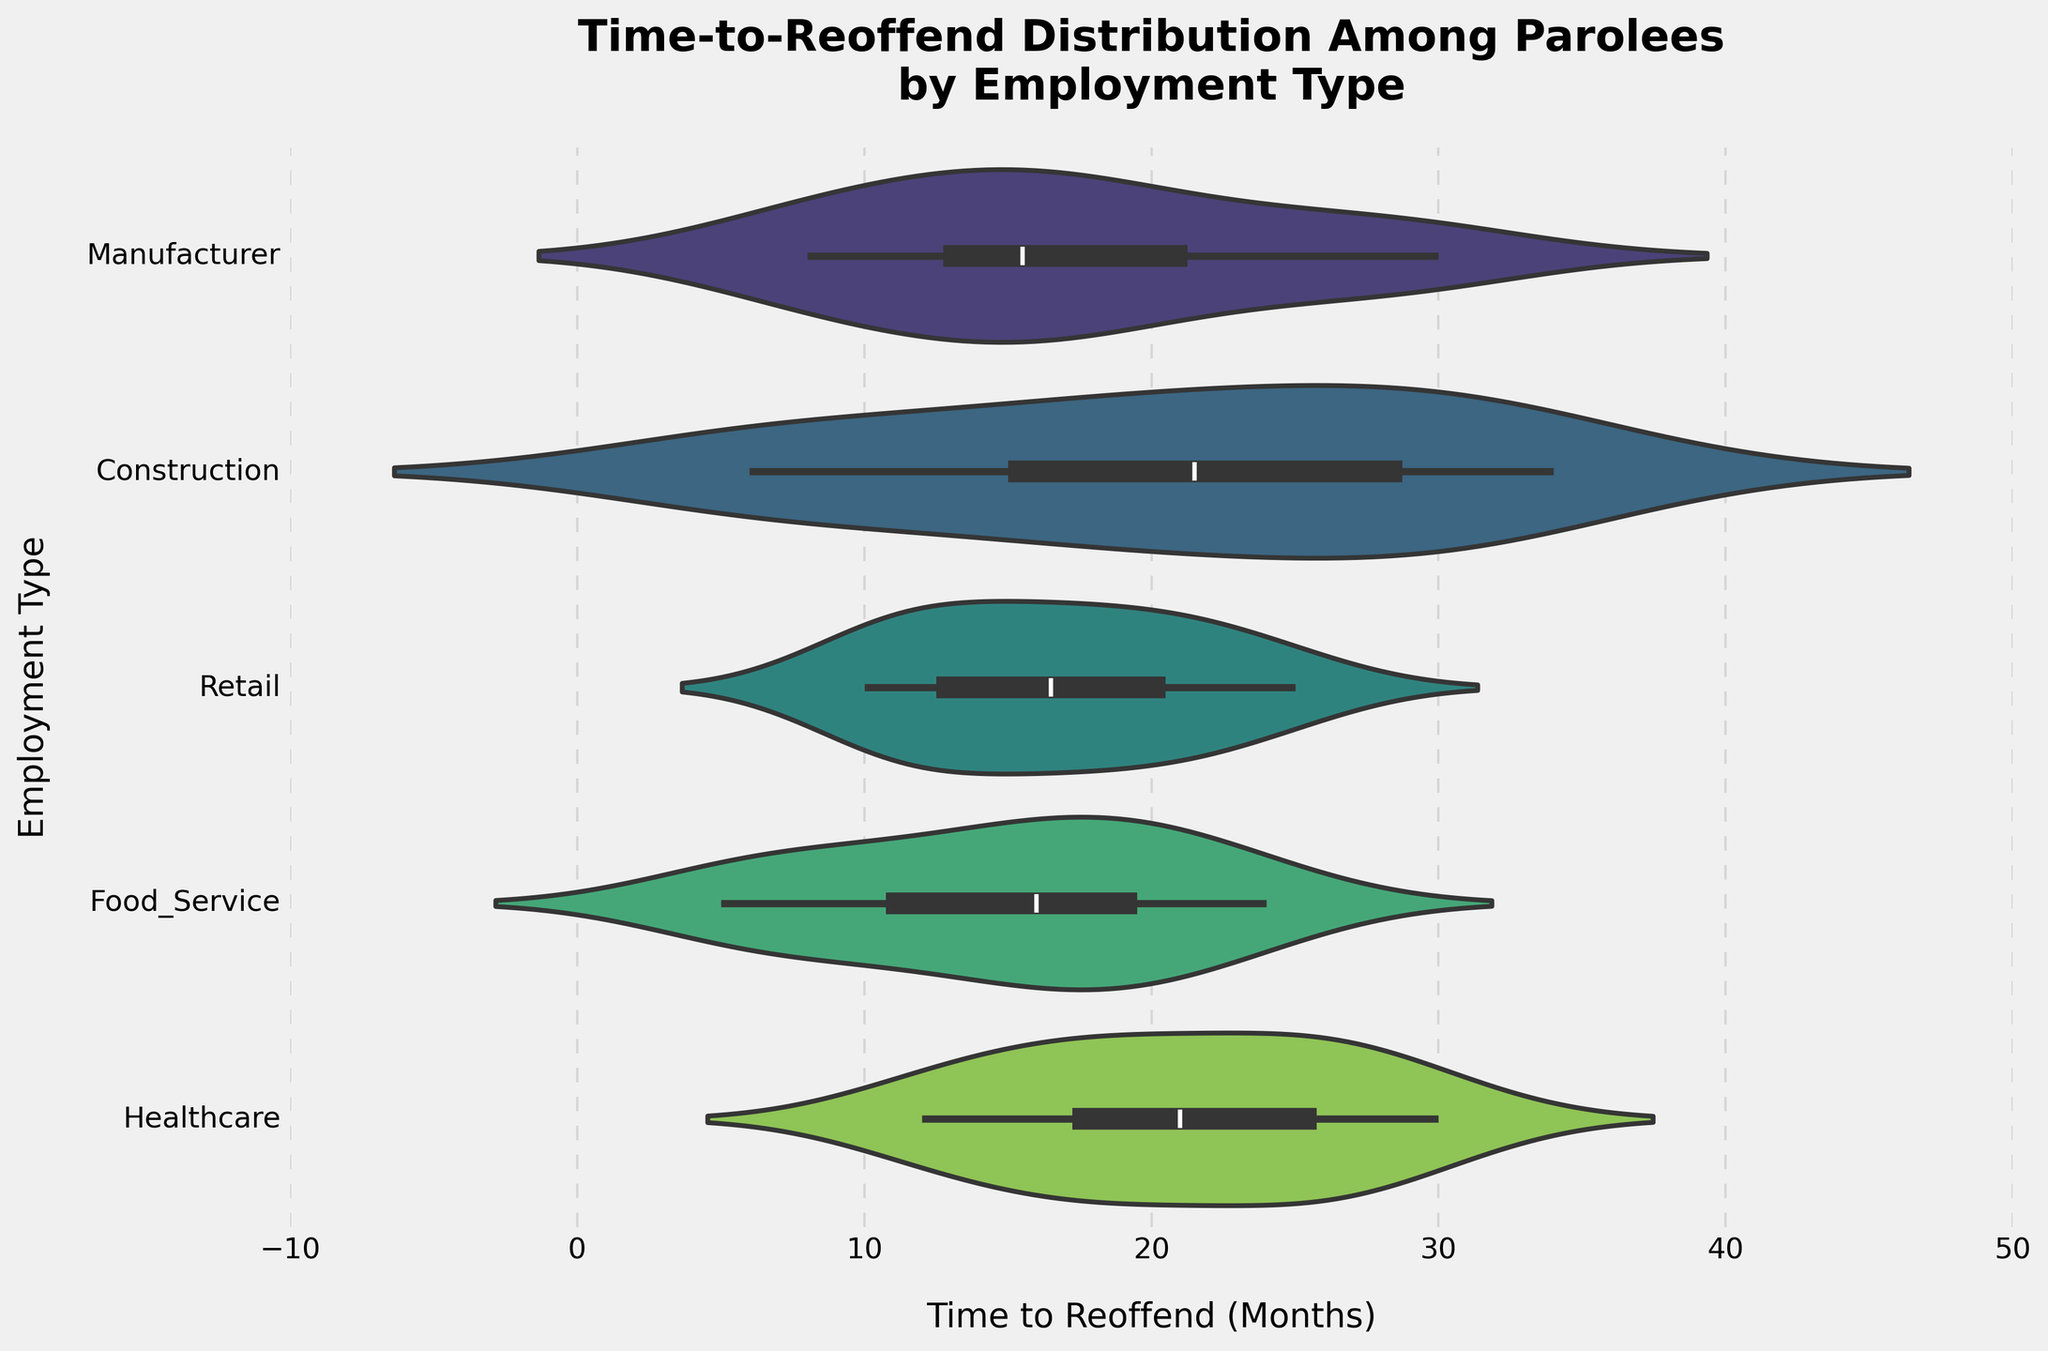What's the title of the chart? The title is usually located at the top of the chart and is in large, bold font. In this case, the title of the chart is "Time-to-Reoffend Distribution Among Parolees by Employment Type"
Answer: Time-to-Reoffend Distribution Among Parolees by Employment Type How many different employment types are shown in the chart? You can count the number of distinct categories along the y-axis to find the number of employment types. In this case, there are five categories: Manufacturer, Construction, Retail, Food Service, and Healthcare
Answer: Five What's the range of the "Time to Reoffend" for the Food Service employment type? By observing the vertical spread of the Food Service violin plot along the x-axis, you can see that it ranges from 5 to 24 months
Answer: 5 to 24 months Which employment type has the widest distribution of "Time to Reoffend"? To determine this, compare the width of each violin plot along the x-axis. The Construction employment type has the widest distribution, ranging from 6 to 34 months
Answer: Construction Which employment type has the median "Time to Reoffend" around 18 months? Locate the inner box (quartile range) within each violin plot and identify which one has the median value around 18 months. Both Construction and Healthcare appear to have medians near 18 months
Answer: Construction and Healthcare How does the distribution of "Time to Reoffend" for the Healthcare employment type compare with that for the Manufacturer employment type? By examining the shape and spread of the Healthcare and Manufacturer violin plots, you can compare their distributions. Healthcare has a wider distribution (12 to 30 months) compared to Manufacturer (8 to 30 months), and Healthcare also shows a slight bias towards higher reoffend times
Answer: Healthcare has a wider distribution; Manufacturer is more evenly spread Which employment type has the smallest range in "Time to Reoffend"? By examining the spread of each violin plot along the x-axis, you can identify which distribution is the narrowest. Retail has the smallest range, from 10 to 25 months
Answer: Retail Is there any employment type for which the distribution of "Time to Reoffend" is skewed? Look at the shape of the violin plots to see if they are symmetrical or skewed (bulging more on one side). The Manufacturer distribution is slightly skewed towards shorter reoffend times (mode around 15 months)
Answer: Manufacturer is slightly skewed to shorter times What is the interquartile range (IQR) for the Construction employment type? The interquartile range (IQR) can be estimated by looking at the inner box in the Construction plot. It appears to span from approximately 14 months to 29 months, so the IQR is 29 - 14 = 15 months
Answer: Approximately 15 months Which employment type shows a bimodal distribution in "Time to Reoffend"? Check if any of the violin plots have two distinct peaks. The Food Service employment type shows a bimodal distribution with peaks around 10 and 20 months
Answer: Food Service 